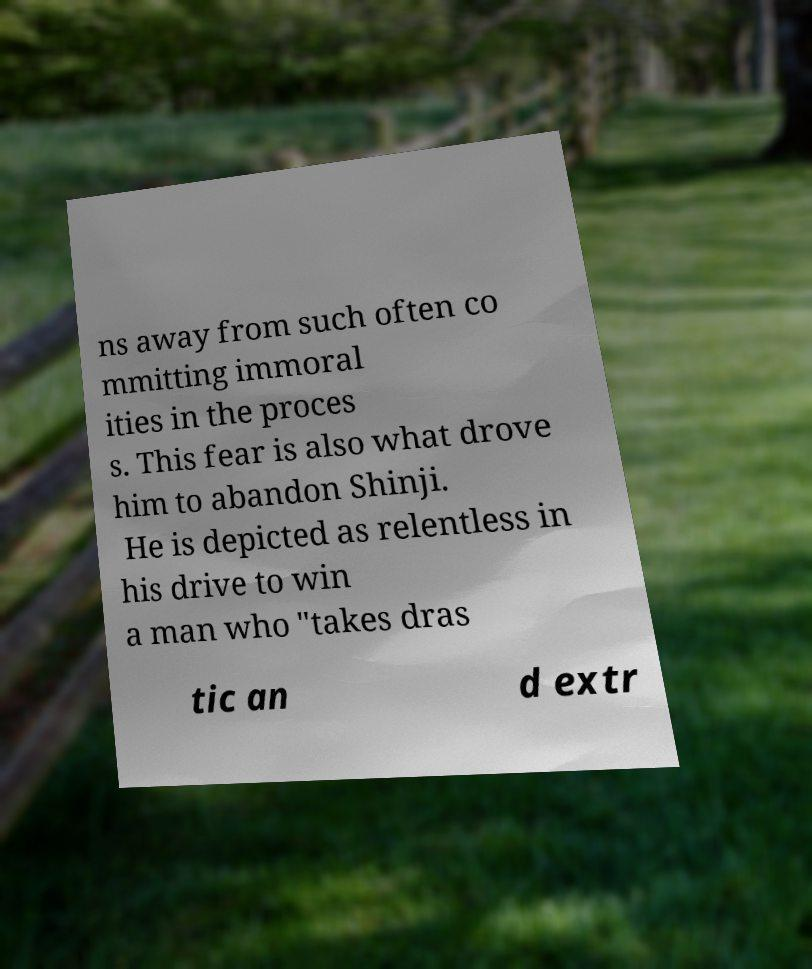Could you assist in decoding the text presented in this image and type it out clearly? ns away from such often co mmitting immoral ities in the proces s. This fear is also what drove him to abandon Shinji. He is depicted as relentless in his drive to win a man who "takes dras tic an d extr 